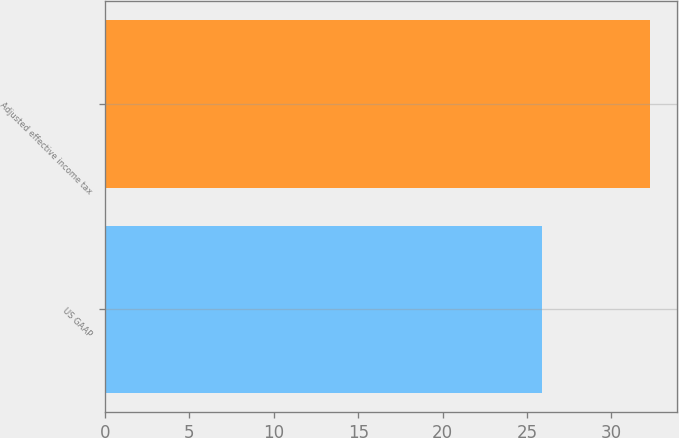Convert chart. <chart><loc_0><loc_0><loc_500><loc_500><bar_chart><fcel>US GAAP<fcel>Adjusted effective income tax<nl><fcel>25.9<fcel>32.3<nl></chart> 